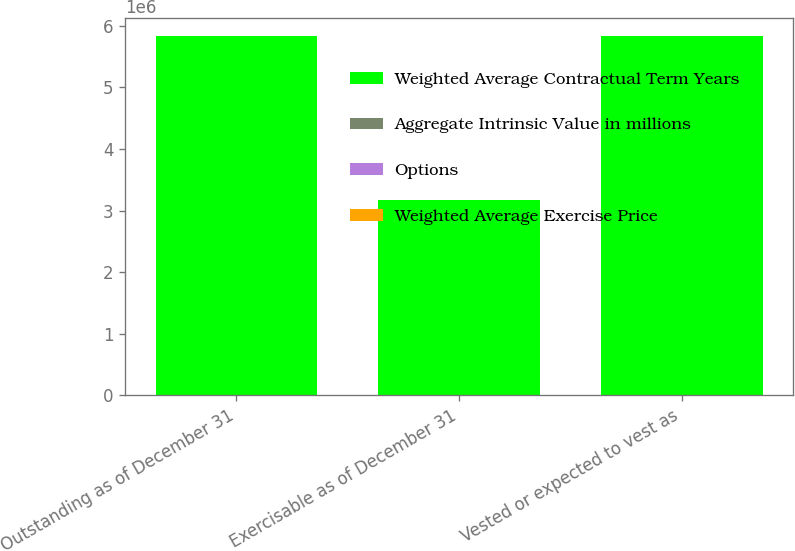<chart> <loc_0><loc_0><loc_500><loc_500><stacked_bar_chart><ecel><fcel>Outstanding as of December 31<fcel>Exercisable as of December 31<fcel>Vested or expected to vest as<nl><fcel>Weighted Average Contractual Term Years<fcel>5.82994e+06<fcel>3.1705e+06<fcel>5.82994e+06<nl><fcel>Aggregate Intrinsic Value in millions<fcel>44.09<fcel>37.07<fcel>44.09<nl><fcel>Options<fcel>6.42<fcel>4.86<fcel>6.42<nl><fcel>Weighted Average Exercise Price<fcel>193.45<fcel>127.46<fcel>193.45<nl></chart> 